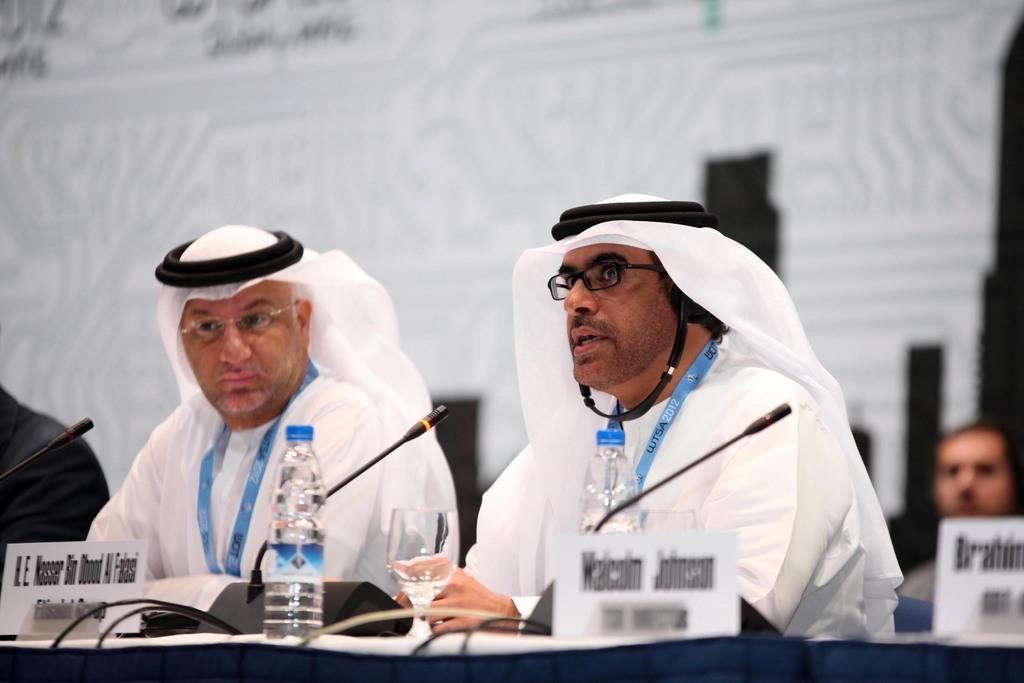What objects are in the foreground of the picture? There are water bottles, mics, name plates, a table, cables, and people sitting in the foreground of the picture. What type of equipment is visible in the image? Mics are visible in the foreground of the picture. What might be used for identification purposes in the image? Name plates are present in the foreground of the picture. What is the primary surface in the foreground of the picture? There is a table in the foreground of the picture. What might be used for connecting or powering devices in the image? Cables are present in the foreground of the picture. How many people are sitting in the foreground of the picture? There are people sitting in the foreground of the picture. What can be observed about the background of the image? The background of the image is blurred. Can you see any fish swimming in the water bottles in the image? There are no fish present in the image, and the water bottles do not contain any water for fish to swim in. 